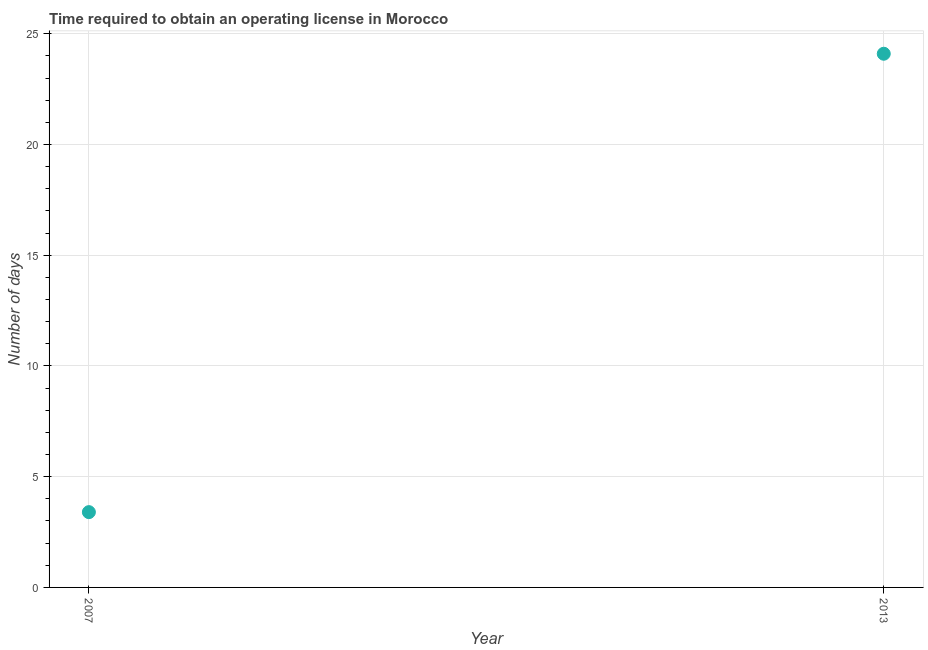Across all years, what is the maximum number of days to obtain operating license?
Your answer should be compact. 24.1. Across all years, what is the minimum number of days to obtain operating license?
Give a very brief answer. 3.4. In which year was the number of days to obtain operating license maximum?
Give a very brief answer. 2013. What is the sum of the number of days to obtain operating license?
Make the answer very short. 27.5. What is the difference between the number of days to obtain operating license in 2007 and 2013?
Make the answer very short. -20.7. What is the average number of days to obtain operating license per year?
Your response must be concise. 13.75. What is the median number of days to obtain operating license?
Your answer should be compact. 13.75. Do a majority of the years between 2013 and 2007 (inclusive) have number of days to obtain operating license greater than 2 days?
Make the answer very short. No. What is the ratio of the number of days to obtain operating license in 2007 to that in 2013?
Your answer should be compact. 0.14. Is the number of days to obtain operating license in 2007 less than that in 2013?
Your answer should be very brief. Yes. Does the number of days to obtain operating license monotonically increase over the years?
Give a very brief answer. Yes. How many dotlines are there?
Your answer should be compact. 1. Are the values on the major ticks of Y-axis written in scientific E-notation?
Make the answer very short. No. Does the graph contain any zero values?
Your answer should be compact. No. What is the title of the graph?
Ensure brevity in your answer.  Time required to obtain an operating license in Morocco. What is the label or title of the Y-axis?
Ensure brevity in your answer.  Number of days. What is the Number of days in 2013?
Offer a terse response. 24.1. What is the difference between the Number of days in 2007 and 2013?
Provide a succinct answer. -20.7. What is the ratio of the Number of days in 2007 to that in 2013?
Keep it short and to the point. 0.14. 